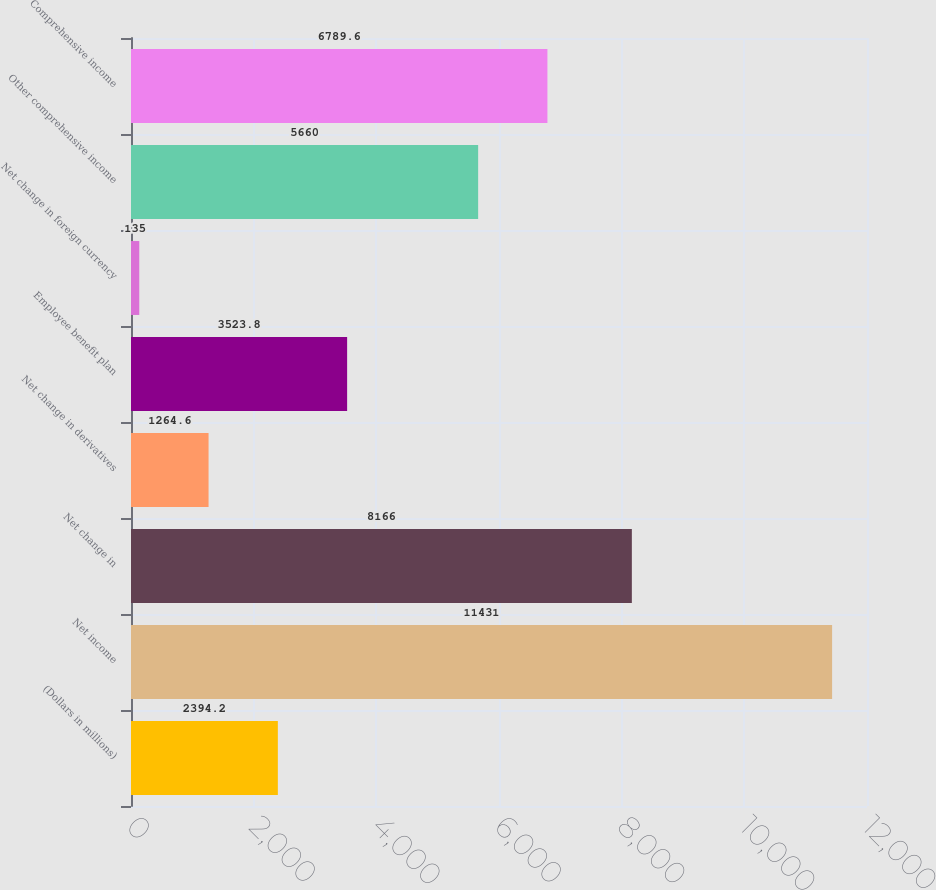<chart> <loc_0><loc_0><loc_500><loc_500><bar_chart><fcel>(Dollars in millions)<fcel>Net income<fcel>Net change in<fcel>Net change in derivatives<fcel>Employee benefit plan<fcel>Net change in foreign currency<fcel>Other comprehensive income<fcel>Comprehensive income<nl><fcel>2394.2<fcel>11431<fcel>8166<fcel>1264.6<fcel>3523.8<fcel>135<fcel>5660<fcel>6789.6<nl></chart> 